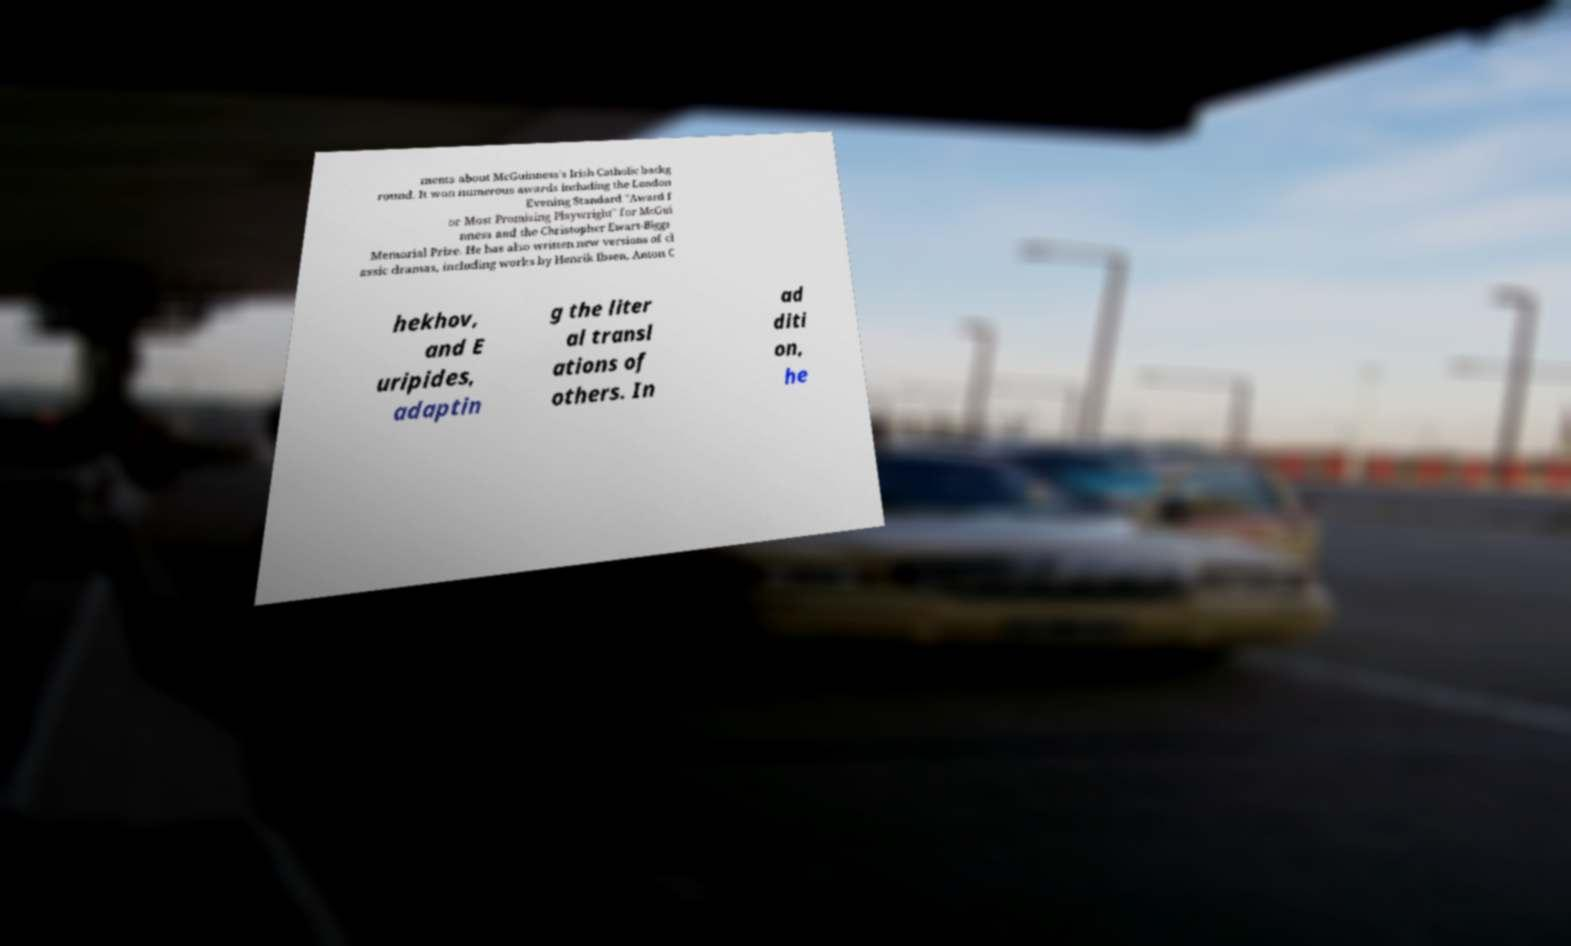For documentation purposes, I need the text within this image transcribed. Could you provide that? ments about McGuinness's Irish Catholic backg round. It won numerous awards including the London Evening Standard "Award f or Most Promising Playwright" for McGui nness and the Christopher Ewart-Biggs Memorial Prize. He has also written new versions of cl assic dramas, including works by Henrik Ibsen, Anton C hekhov, and E uripides, adaptin g the liter al transl ations of others. In ad diti on, he 